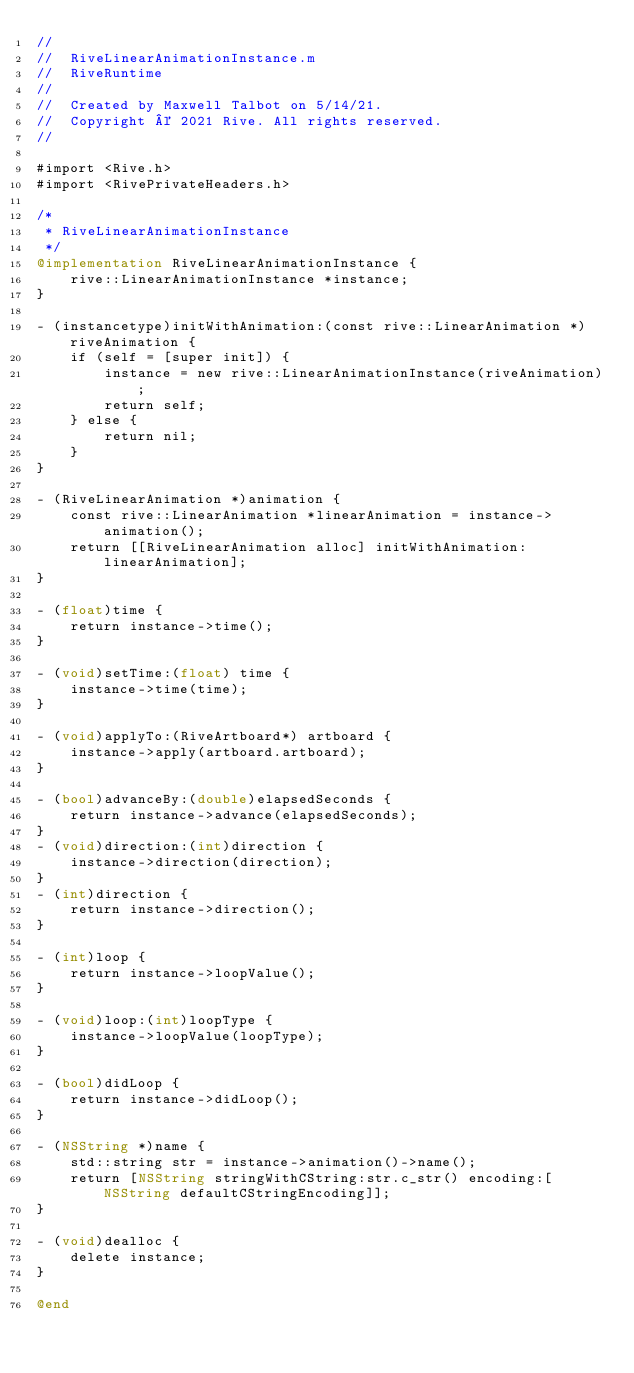<code> <loc_0><loc_0><loc_500><loc_500><_ObjectiveC_>//
//  RiveLinearAnimationInstance.m
//  RiveRuntime
//
//  Created by Maxwell Talbot on 5/14/21.
//  Copyright © 2021 Rive. All rights reserved.
//

#import <Rive.h>
#import <RivePrivateHeaders.h>

/*
 * RiveLinearAnimationInstance
 */
@implementation RiveLinearAnimationInstance {
    rive::LinearAnimationInstance *instance;
}

- (instancetype)initWithAnimation:(const rive::LinearAnimation *)riveAnimation {
    if (self = [super init]) {
        instance = new rive::LinearAnimationInstance(riveAnimation);
        return self;
    } else {
        return nil;
    }
}

- (RiveLinearAnimation *)animation {
    const rive::LinearAnimation *linearAnimation = instance->animation();
    return [[RiveLinearAnimation alloc] initWithAnimation: linearAnimation];
}

- (float)time {
    return instance->time();
}

- (void)setTime:(float) time {
    instance->time(time);
}

- (void)applyTo:(RiveArtboard*) artboard {
    instance->apply(artboard.artboard);
}

- (bool)advanceBy:(double)elapsedSeconds {
    return instance->advance(elapsedSeconds);
}
- (void)direction:(int)direction {
    instance->direction(direction);
}
- (int)direction {
    return instance->direction();
}

- (int)loop {
    return instance->loopValue();
}

- (void)loop:(int)loopType {
    instance->loopValue(loopType);
}

- (bool)didLoop {
    return instance->didLoop();
}

- (NSString *)name {
    std::string str = instance->animation()->name();
    return [NSString stringWithCString:str.c_str() encoding:[NSString defaultCStringEncoding]];
}

- (void)dealloc {
    delete instance;
}

@end
</code> 